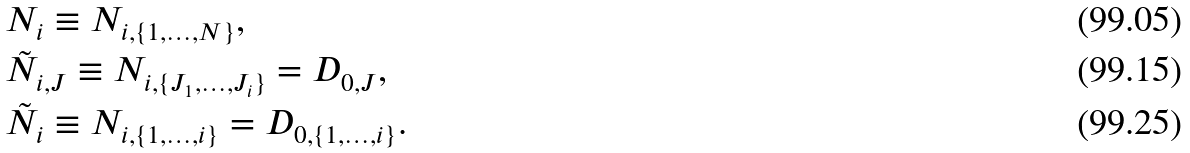<formula> <loc_0><loc_0><loc_500><loc_500>& N _ { i } \equiv N _ { i , \{ 1 , \dots , N \} } , \\ & \tilde { N } _ { i , J } \equiv N _ { i , \{ J _ { 1 } , \dots , J _ { i } \} } = D _ { 0 , J } , \\ & \tilde { N } _ { i } \equiv N _ { i , \{ 1 , \dots , i \} } = D _ { 0 , \{ 1 , \dots , i \} } .</formula> 